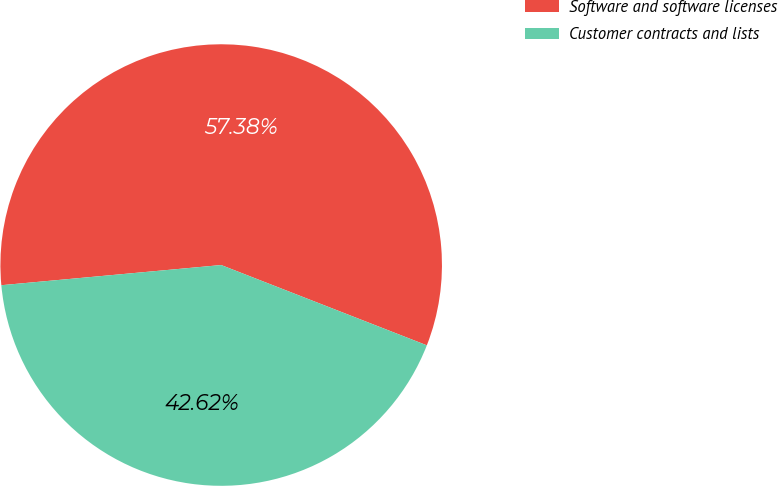Convert chart to OTSL. <chart><loc_0><loc_0><loc_500><loc_500><pie_chart><fcel>Software and software licenses<fcel>Customer contracts and lists<nl><fcel>57.38%<fcel>42.62%<nl></chart> 